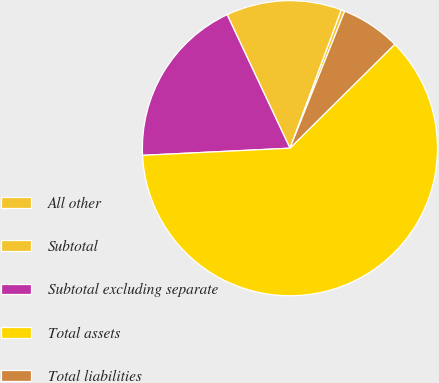<chart> <loc_0><loc_0><loc_500><loc_500><pie_chart><fcel>All other<fcel>Subtotal<fcel>Subtotal excluding separate<fcel>Total assets<fcel>Total liabilities<nl><fcel>0.4%<fcel>12.65%<fcel>18.77%<fcel>61.66%<fcel>6.52%<nl></chart> 